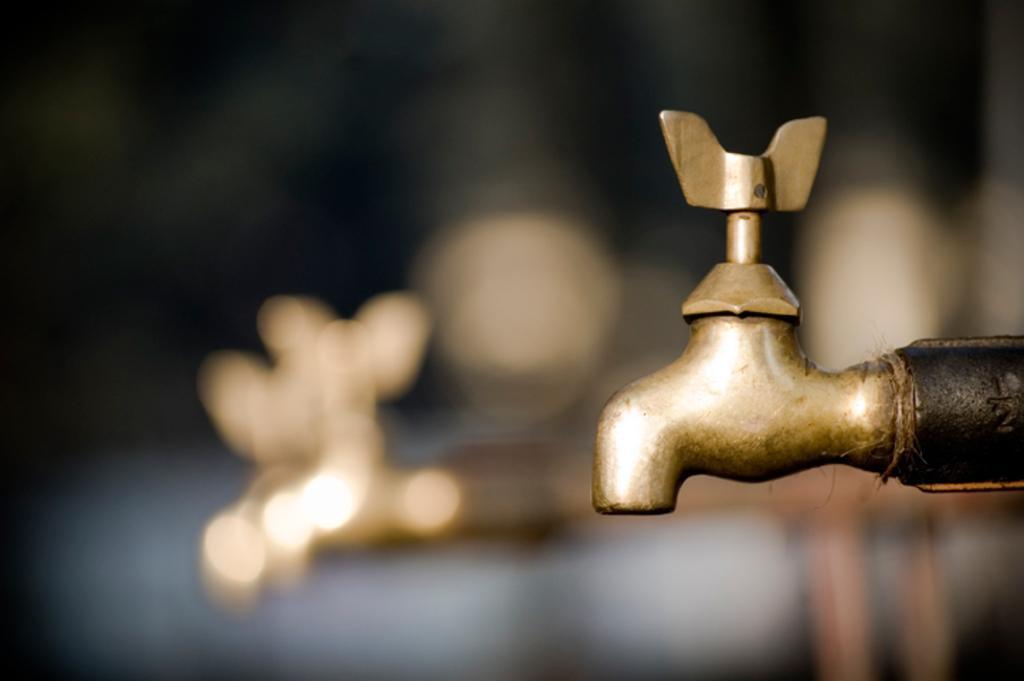Could you give a brief overview of what you see in this image? In this image we can see a tap. There is a blur background and we can see a tap. 